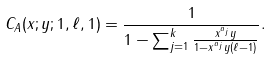Convert formula to latex. <formula><loc_0><loc_0><loc_500><loc_500>C _ { A } ( x ; y ; 1 , \ell , 1 ) = \frac { 1 } { 1 - \sum _ { j = 1 } ^ { k } \frac { x ^ { a _ { j } } y } { 1 - x ^ { a _ { j } } y ( \ell - 1 ) } } .</formula> 